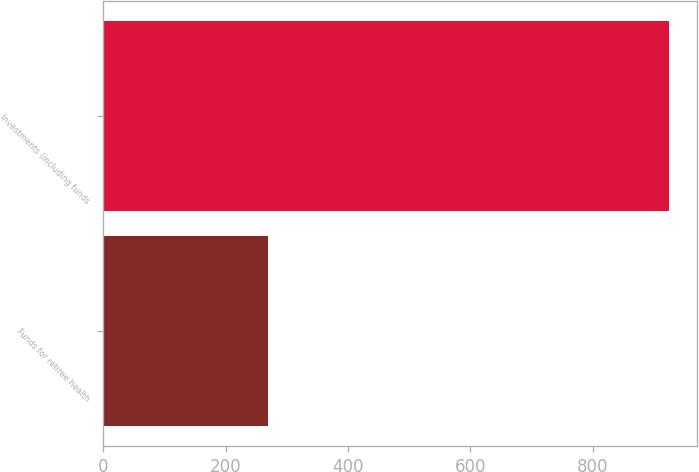Convert chart. <chart><loc_0><loc_0><loc_500><loc_500><bar_chart><fcel>Funds for retiree health<fcel>Investments (including funds<nl><fcel>270<fcel>924<nl></chart> 